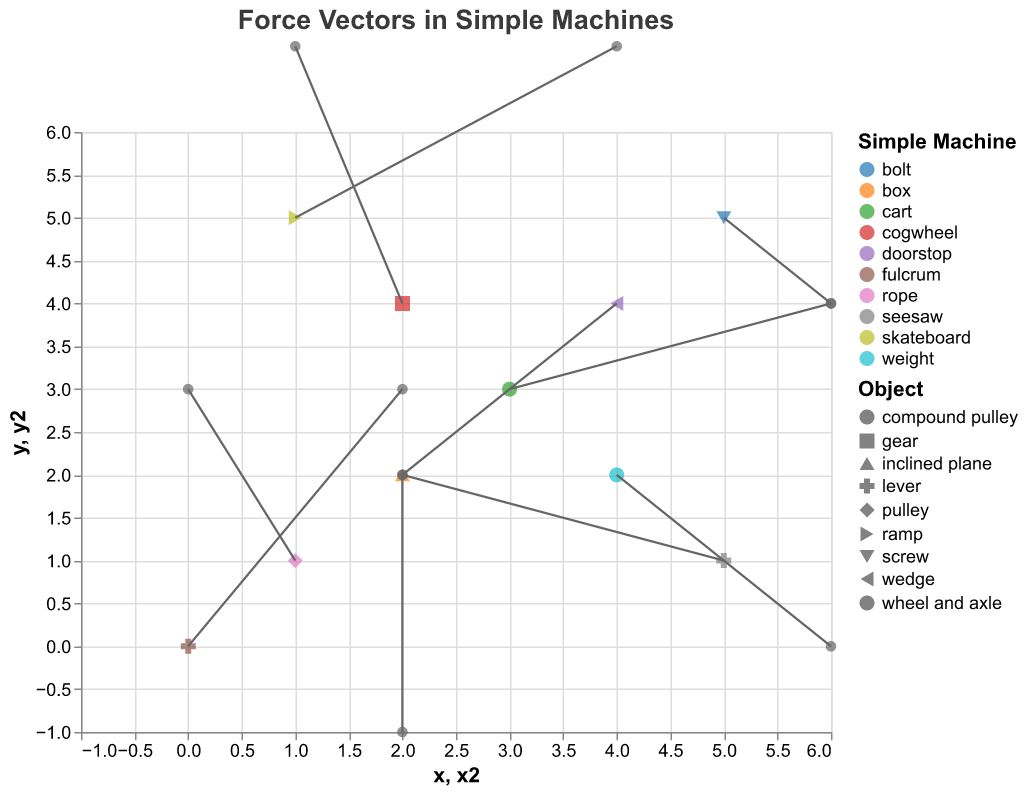How many force vectors are acting on levers? To determine the number of force vectors acting on levers, we need to count the entries with "lever" in the 'object' column. There are two such entries.
Answer: 2 What is the direction of the force vector acting on the wedge? The force vector is defined using u and v components. For the wedge, the values are u = -2 and v = -2, indicating a southwest direction.
Answer: Southwest Which simple machine has the highest vertical force component? Comparing the v components of all vectors, the highest v value is 3. Therefore, the machines with this vertical force component are the fulcrum (lever) and the cogwheel (gear).
Answer: Fulcrum and Cogwheel What is the sum of the horizontal force components for the objects located at (1,1) and (5,1)? The horizontal components (u values) at these coordinates are -1 and -3, respectively. Summing them gives -1 + (-3) = -4.
Answer: -4 Which force vector has the greatest magnitude, and what is its value? Calculate the magnitude using the formula sqrt(u^2 + v^2) for each vector. The vector (3, 3) with u = 3, v = 2 has the largest magnitude, sqrt(3^2 + 2^2) = sqrt(13) ≈ 3.6.
Answer: (3, 3) with magnitude 3.6 What is the positional transformation of the force acting on the skateboard from the initial point? The initial point is (1,5), and the force vector is (3, 2). The transformed position is (1+3, 5+2) = (4, 7).
Answer: (4, 7) Which two machines have force vectors that end at the same position? Calculate the endpoint positions of all vectors. The initial points (x,y) are added to their respective vectors (u,v). The vectors ending at the same position are from (4,2) with vector (2,-2) and (2,4) with vector (-1,3), both ending at (6,0).
Answer: Compound Pulley and Gear 